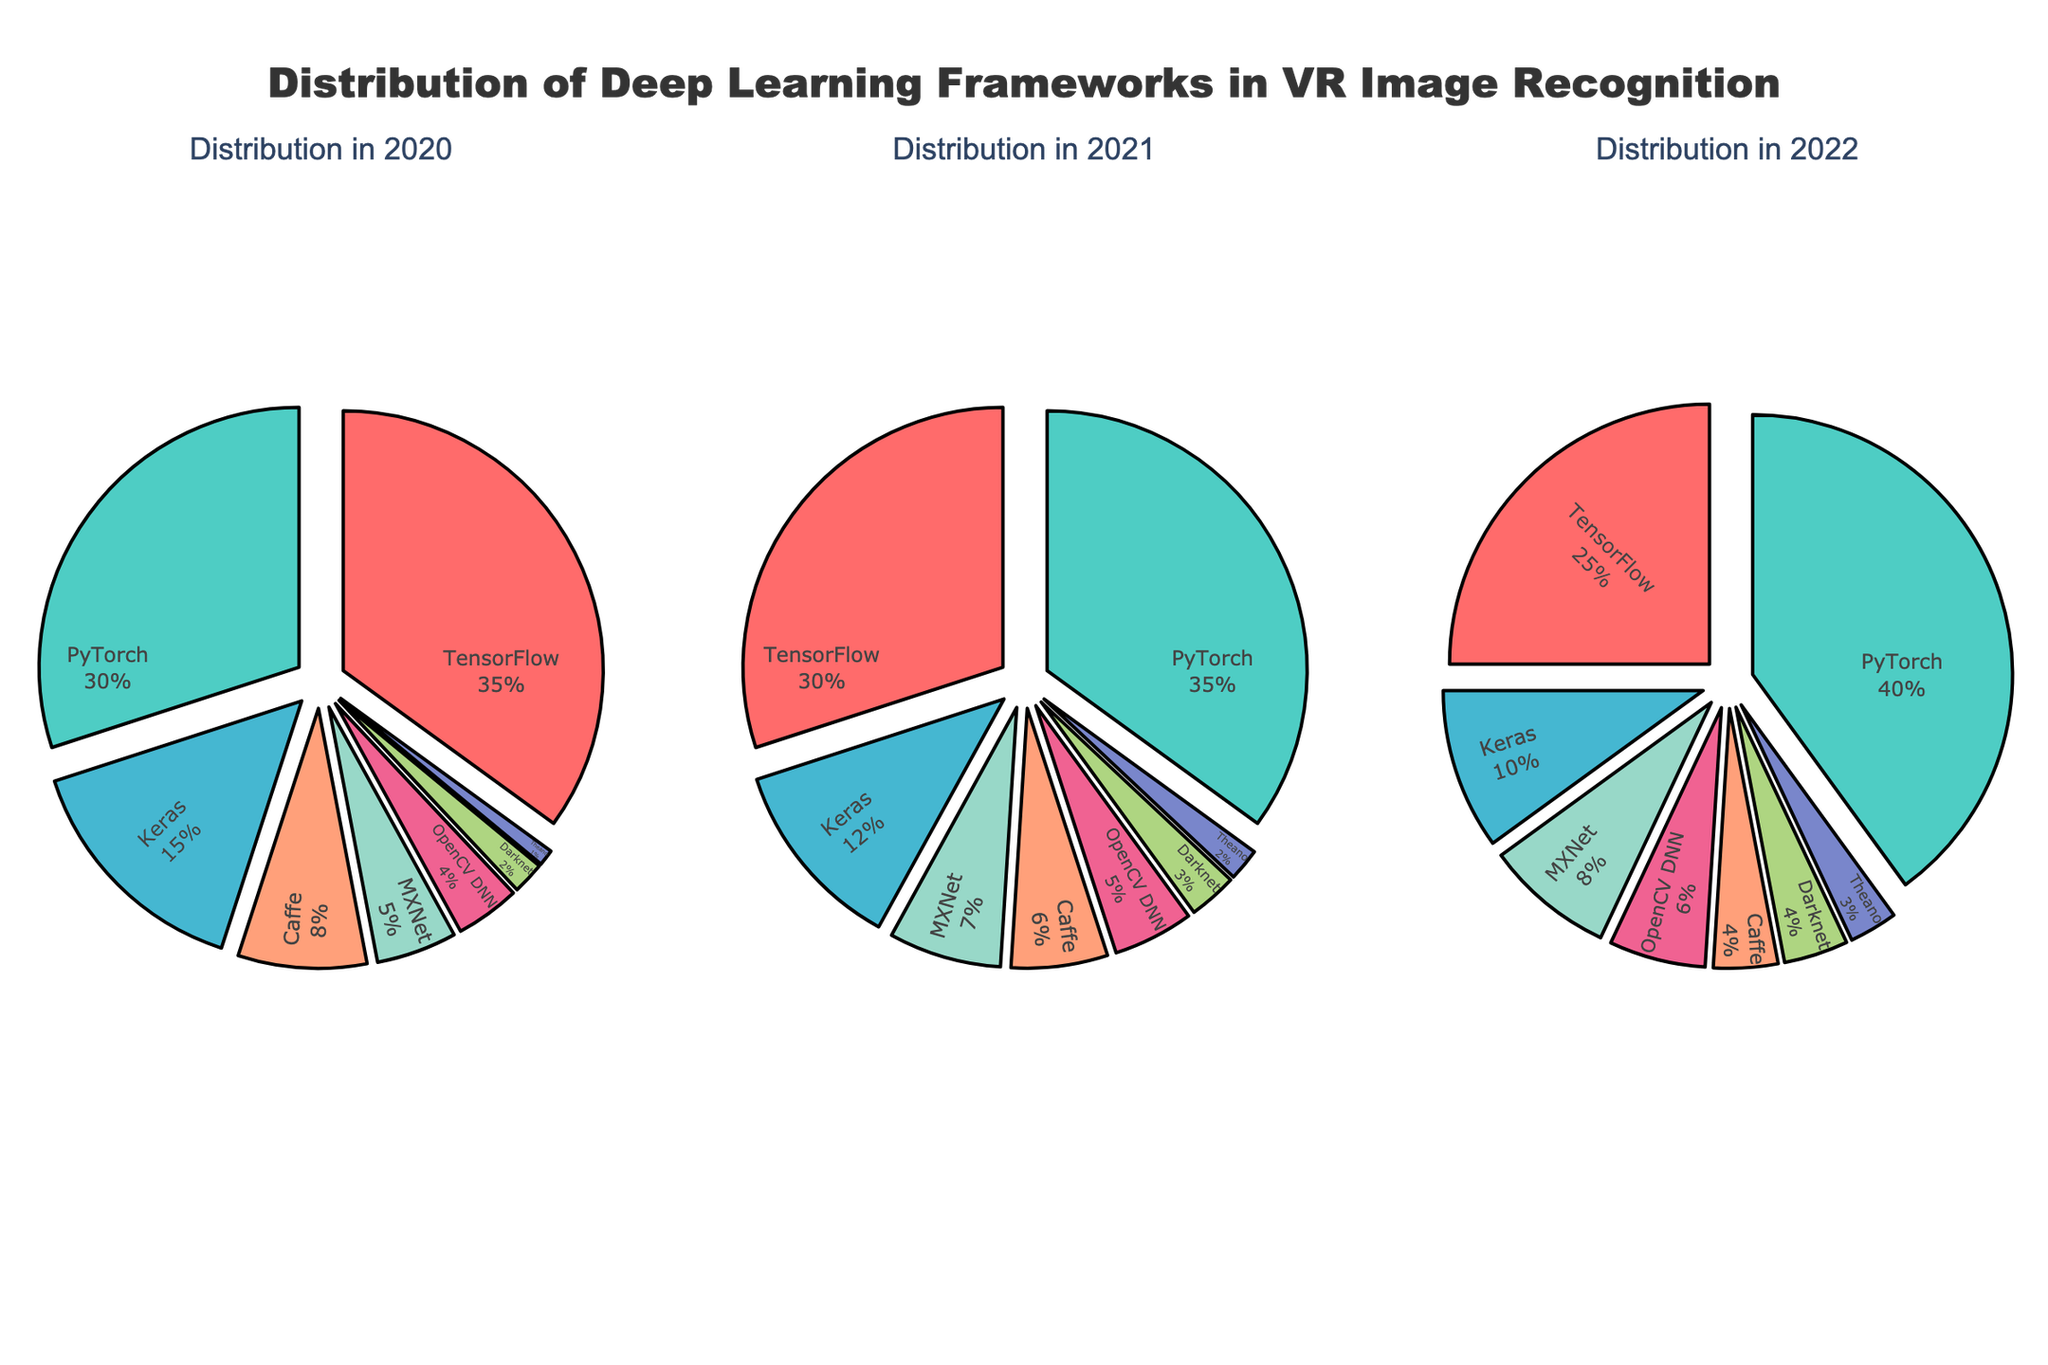What's the main title of the figure? The main title is usually located at the top of the figure, prominently displayed to give an overview of what the figure represents. Here, it reads "Distribution of Deep Learning Frameworks in VR Image Recognition".
Answer: Distribution of Deep Learning Frameworks in VR Image Recognition Which framework had the highest usage in 2022? To find the framework with the highest usage in 2022, look at the largest segment of the pie chart for 2022. PyTorch has the largest segment.
Answer: PyTorch How has the usage of TensorFlow changed from 2020 to 2022? By comparing the pie charts across the years, we see that the percentage for TensorFlow decreases as we move from 2020 (35%) to 2022 (25%). This indicates a decline in usage.
Answer: Decreased Which framework showed a consistent increase in usage over the years? By examining the segments for each framework across the three years, PyTorch shows an increase from 30% (2020) to 35% (2021) and then to 40% (2022).
Answer: PyTorch In 2021, which two frameworks had the smallest usage? Look at the pie chart for 2021 and find the two smallest segments. Darknet and Theano have the smallest usage.
Answer: Darknet and Theano What was the combined usage percentage of MXNet and OpenCV DNN in 2022? Check the 2022 pie chart for the percentages of MXNet and OpenCV DNN and add them together. MXNet has 8% and OpenCV DNN has 6%. The combined percentage is 8% + 6% = 14%.
Answer: 14% Which year saw the highest percentage usage of Keras? Compare the Keras segments across all three years. Keras had the highest percentage in 2020, with 15%.
Answer: 2020 How did the usage of Caffe change from 2021 to 2022? Look at the pie chart segments for Caffe in 2021 and 2022. The percentage decreased from 6% in 2021 to 4% in 2022.
Answer: Decreased Did any framework show a declining trend over the three years? By examining each framework's segments over the three years, TensorFlow and Keras both showed a declining trend from 2020 to 2022.
Answer: TensorFlow and Keras Which framework had a higher increase in usage from 2020 to 2022, PyTorch or Theano? Calculate the difference in percentages from 2020 to 2022 for both frameworks. PyTorch increased from 30% to 40%, a 10% increase. Theano increased from 1% to 3%, a 2% increase. Thus, PyTorch had a higher increase.
Answer: PyTorch 